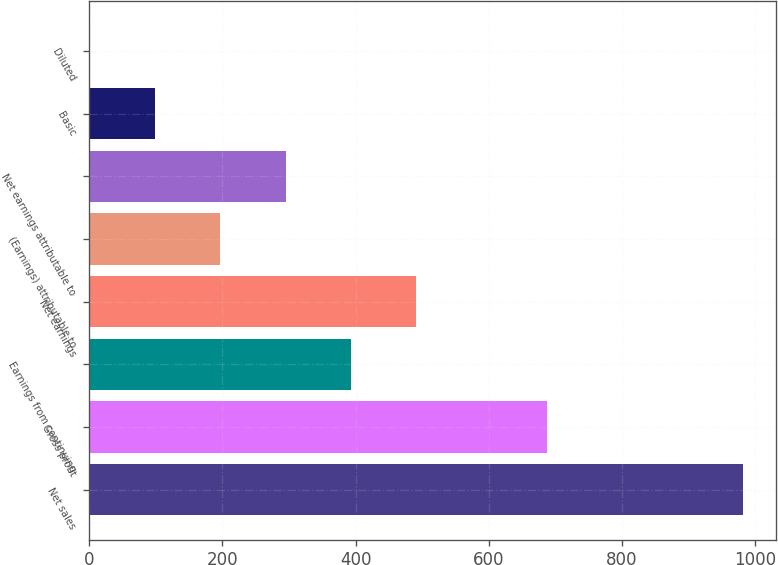<chart> <loc_0><loc_0><loc_500><loc_500><bar_chart><fcel>Net sales<fcel>Gross profit<fcel>Earnings from continuing<fcel>Net earnings<fcel>(Earnings) attributable to<fcel>Net earnings attributable to<fcel>Basic<fcel>Diluted<nl><fcel>982.2<fcel>687.7<fcel>393.17<fcel>491.35<fcel>196.81<fcel>294.99<fcel>98.63<fcel>0.45<nl></chart> 